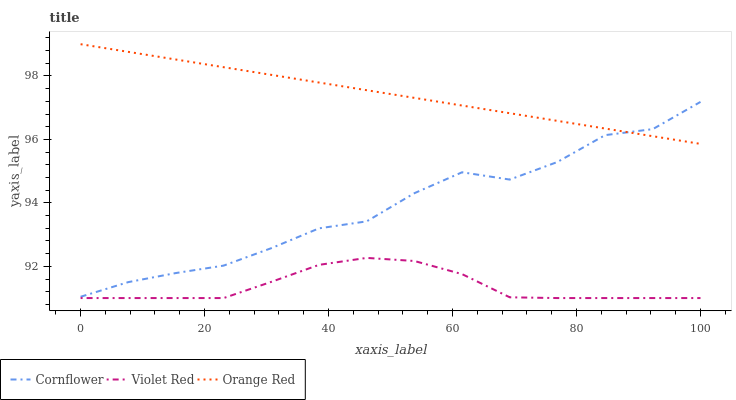Does Violet Red have the minimum area under the curve?
Answer yes or no. Yes. Does Orange Red have the maximum area under the curve?
Answer yes or no. Yes. Does Orange Red have the minimum area under the curve?
Answer yes or no. No. Does Violet Red have the maximum area under the curve?
Answer yes or no. No. Is Orange Red the smoothest?
Answer yes or no. Yes. Is Cornflower the roughest?
Answer yes or no. Yes. Is Violet Red the smoothest?
Answer yes or no. No. Is Violet Red the roughest?
Answer yes or no. No. Does Violet Red have the lowest value?
Answer yes or no. Yes. Does Orange Red have the lowest value?
Answer yes or no. No. Does Orange Red have the highest value?
Answer yes or no. Yes. Does Violet Red have the highest value?
Answer yes or no. No. Is Violet Red less than Cornflower?
Answer yes or no. Yes. Is Orange Red greater than Violet Red?
Answer yes or no. Yes. Does Orange Red intersect Cornflower?
Answer yes or no. Yes. Is Orange Red less than Cornflower?
Answer yes or no. No. Is Orange Red greater than Cornflower?
Answer yes or no. No. Does Violet Red intersect Cornflower?
Answer yes or no. No. 